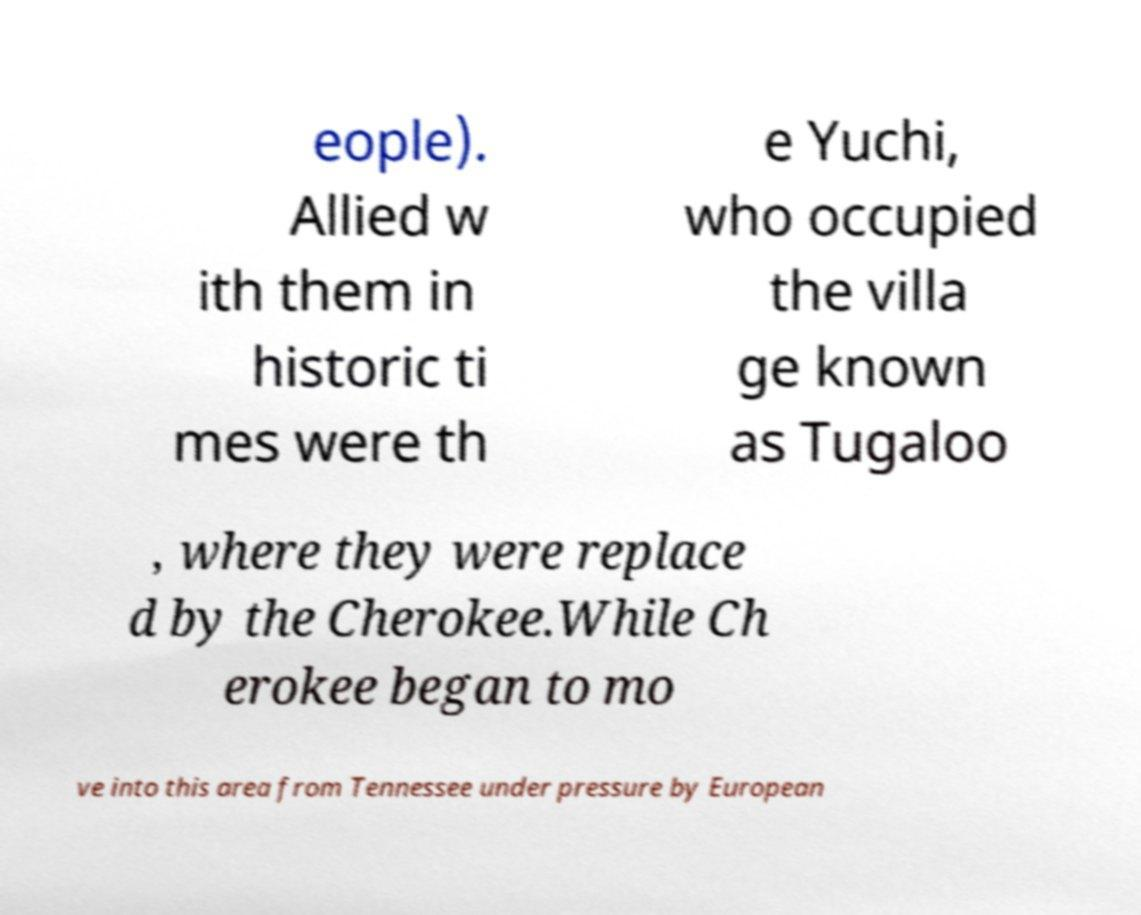Could you extract and type out the text from this image? eople). Allied w ith them in historic ti mes were th e Yuchi, who occupied the villa ge known as Tugaloo , where they were replace d by the Cherokee.While Ch erokee began to mo ve into this area from Tennessee under pressure by European 